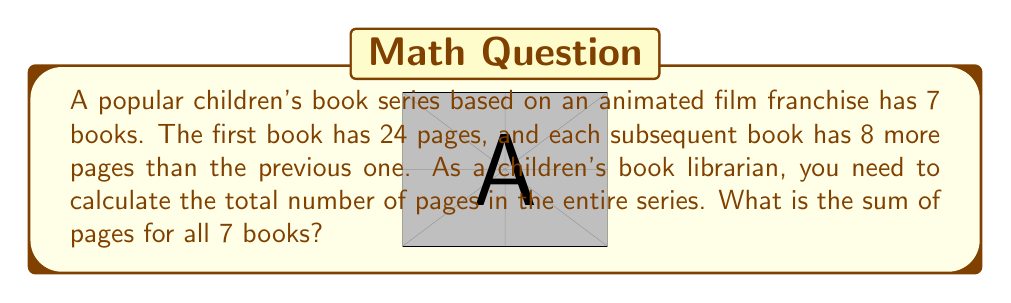Show me your answer to this math problem. Let's approach this step-by-step:

1) We can recognize this as an arithmetic sequence, where:
   - The first term, $a_1 = 24$
   - The common difference, $d = 8$
   - The number of terms, $n = 7$

2) The formula for the nth term of an arithmetic sequence is:
   $a_n = a_1 + (n-1)d$

3) We can find the last term (7th book) using this formula:
   $a_7 = 24 + (7-1)8 = 24 + 48 = 72$

4) For the sum of an arithmetic sequence, we use the formula:
   $S_n = \frac{n}{2}(a_1 + a_n)$

   Where $S_n$ is the sum of $n$ terms, $a_1$ is the first term, and $a_n$ is the last term.

5) Substituting our values:
   $S_7 = \frac{7}{2}(24 + 72)$

6) Simplifying:
   $S_7 = \frac{7}{2}(96) = 7 * 48 = 336$

Therefore, the total number of pages in the series is 336.
Answer: 336 pages 